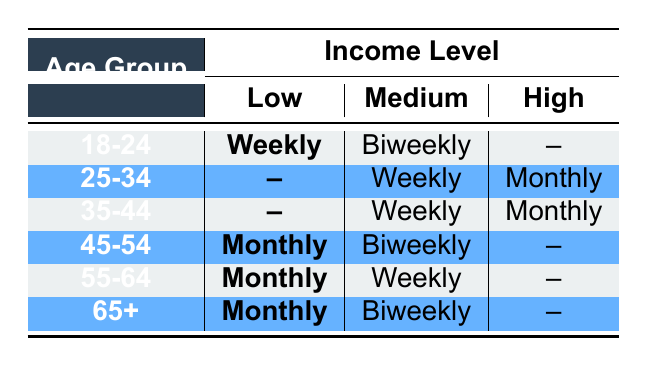What is the Purchase Frequency for the 18-24 Age Group with Low Income? According to the table, under the 18-24 age group and with a low income level, the corresponding purchase frequency is listed as "Weekly."
Answer: Weekly What is the Purchase Frequency for the 45-54 Age Group with Medium Income? From the table, for the age group 45-54 and income level medium, the purchase frequency is "Biweekly."
Answer: Biweekly Is there any Age Group that has a High-Income Level and a Purchase Frequency listed? Reviewing the table, there are no entries in the high-income category for any age group that mark any purchase frequencies listed. Therefore, the answer is "No."
Answer: No Which Age Group has the most frequent purchases? By examining the table, the 18-24 age group with low income shows a "Weekly" frequency while the 35-44 age group with medium income also shows "Weekly," which is the most frequent listed among all age groups. Thus, the answer is 18-24 and 35-44, as both display "Weekly."
Answer: 18-24 and 35-44 How many age groups have a purchase frequency of "Monthly"? The table indicates that the following age groups have a "Monthly" purchase frequency: 45-54 (Low), 55-64 (Low), and 65+ (Low). Counting these entries shows there are three age groups with a "Monthly" purchase frequency.
Answer: 3 What are the Income Levels of the 25-34 Age Group? From the table, the 25-34 age group is represented with two income levels: "Medium" with "Weekly" purchase frequency and "High" with "Monthly" purchase frequency. Therefore, the answer combines these income levels.
Answer: Medium, High Are there more age groups with a purchase frequency of "Biweekly" than those with "Monthly"? In the table, "Biweekly" frequency appears under two age groups (18-24 and 65+), while "Monthly" occurs under three age groups (45-54, 55-64, 65+). Thus, the "Monthly" frequency outnumbers the "Biweekly," leading to the answer being "No."
Answer: No What is the highest income level with the lowest purchase frequency present in the table? Checking the table, the 45-54 age group under Low income is associated with a "Monthly" purchase frequency, which is the lowest frequency value given the income grouping.
Answer: High Which age group has no frequency listed in the table? Upon reviewing the table, the age range 25-34 (High) is the only demographic with no corresponding purchase frequency noted.
Answer: 25-34 